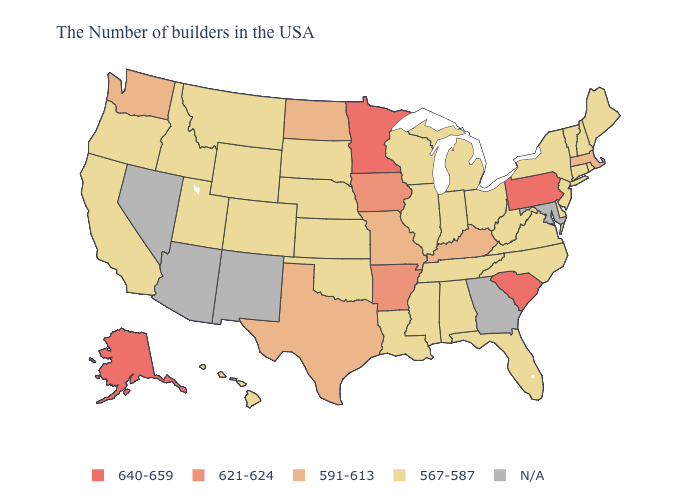Name the states that have a value in the range 621-624?
Short answer required. Arkansas, Iowa. Which states have the lowest value in the USA?
Concise answer only. Maine, Rhode Island, New Hampshire, Vermont, Connecticut, New York, New Jersey, Delaware, Virginia, North Carolina, West Virginia, Ohio, Florida, Michigan, Indiana, Alabama, Tennessee, Wisconsin, Illinois, Mississippi, Louisiana, Kansas, Nebraska, Oklahoma, South Dakota, Wyoming, Colorado, Utah, Montana, Idaho, California, Oregon, Hawaii. What is the highest value in the USA?
Answer briefly. 640-659. What is the highest value in states that border Maine?
Write a very short answer. 567-587. What is the value of Kentucky?
Write a very short answer. 591-613. What is the highest value in the Northeast ?
Keep it brief. 640-659. What is the highest value in states that border Nebraska?
Be succinct. 621-624. Among the states that border Rhode Island , which have the highest value?
Give a very brief answer. Massachusetts. Which states hav the highest value in the MidWest?
Concise answer only. Minnesota. Among the states that border Louisiana , does Arkansas have the highest value?
Write a very short answer. Yes. What is the value of Nebraska?
Concise answer only. 567-587. Which states have the lowest value in the Northeast?
Short answer required. Maine, Rhode Island, New Hampshire, Vermont, Connecticut, New York, New Jersey. 